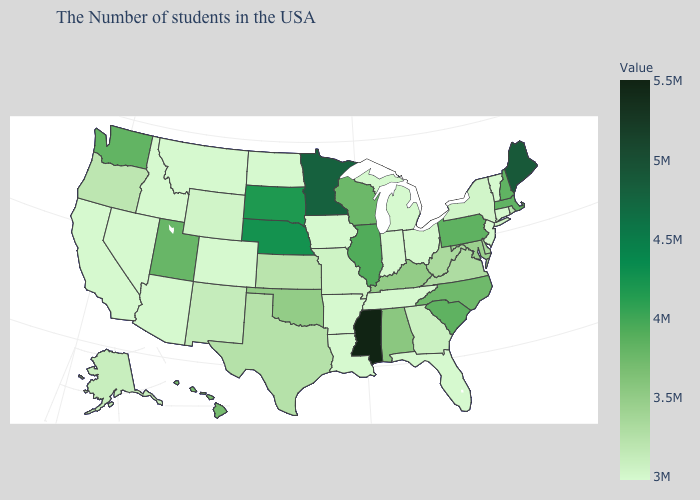Does Minnesota have the lowest value in the MidWest?
Short answer required. No. Does the map have missing data?
Concise answer only. No. Does the map have missing data?
Keep it brief. No. Does North Dakota have the lowest value in the MidWest?
Answer briefly. Yes. 